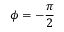Convert formula to latex. <formula><loc_0><loc_0><loc_500><loc_500>\phi = - \frac { \pi } { 2 }</formula> 